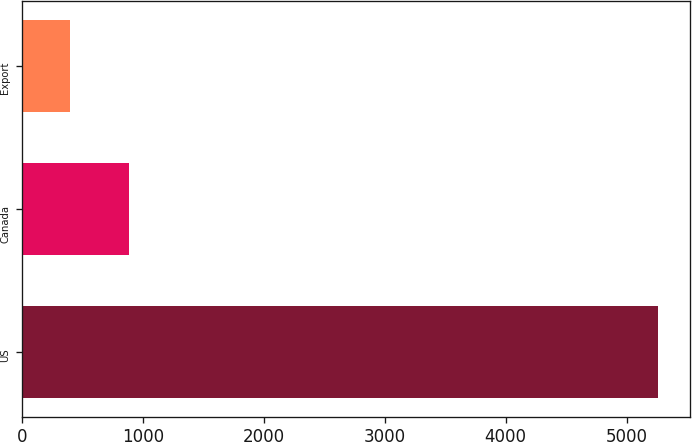Convert chart. <chart><loc_0><loc_0><loc_500><loc_500><bar_chart><fcel>US<fcel>Canada<fcel>Export<nl><fcel>5260.9<fcel>883.12<fcel>396.7<nl></chart> 